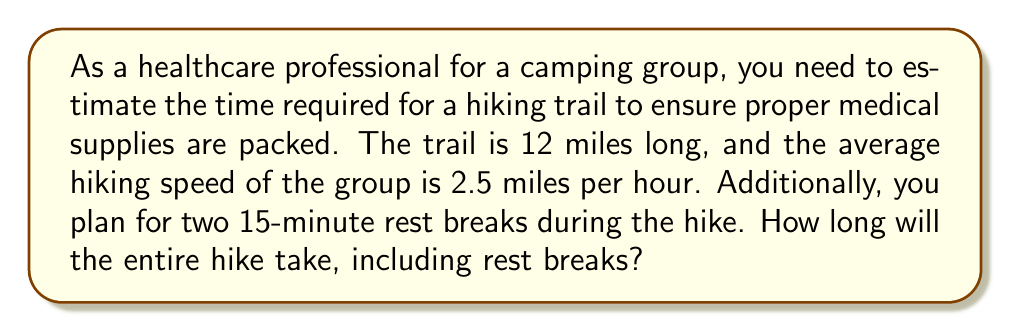Can you solve this math problem? To solve this problem, we'll follow these steps:

1. Calculate the time spent hiking:
   - Distance = 12 miles
   - Rate (speed) = 2.5 miles per hour
   - Time = Distance ÷ Rate
   $$\text{Time} = \frac{12 \text{ miles}}{2.5 \text{ miles/hour}} = 4.8 \text{ hours}$$

2. Convert 4.8 hours to hours and minutes:
   - 4 hours
   - 0.8 hours × 60 minutes/hour = 48 minutes

3. Add the rest break time:
   - Two 15-minute breaks = 30 minutes total

4. Sum up the total time:
   - Hiking time: 4 hours 48 minutes
   - Rest time: 30 minutes
   $$\text{Total time} = 4 \text{ hours } 48 \text{ minutes } + 30 \text{ minutes} = 5 \text{ hours } 18 \text{ minutes}$$
Answer: The entire hike, including rest breaks, will take 5 hours and 18 minutes. 